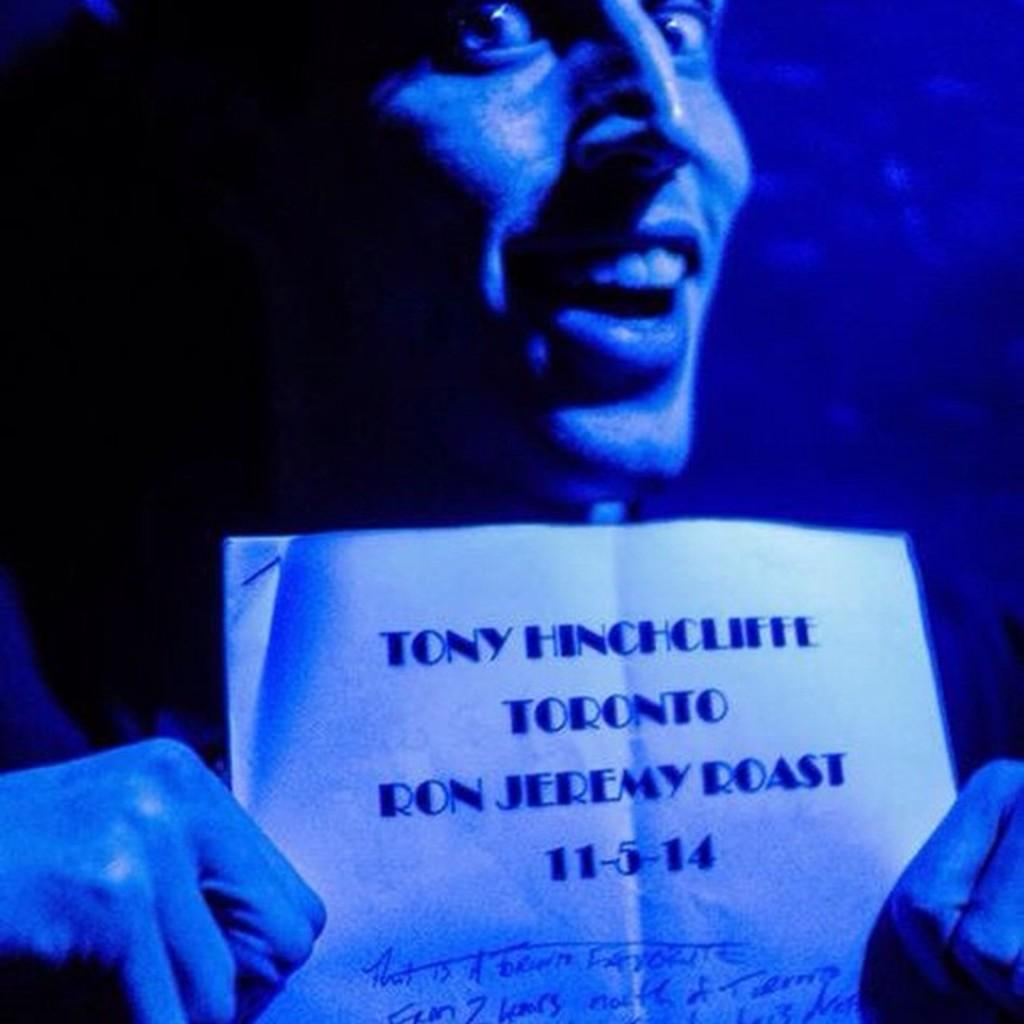What is the main subject of the image? There is a person in the image. What is the person holding in the image? The person is holding a paper. Can you describe the paper in more detail? There is text written on the paper. How does the person twist the memory in the image? There is no mention of twisting or memory in the image; it only shows a person holding a paper with text on it. 